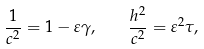Convert formula to latex. <formula><loc_0><loc_0><loc_500><loc_500>\frac { 1 } { c ^ { 2 } } = 1 - \varepsilon \gamma , \quad \frac { h ^ { 2 } } { c ^ { 2 } } = \varepsilon ^ { 2 } \tau ,</formula> 